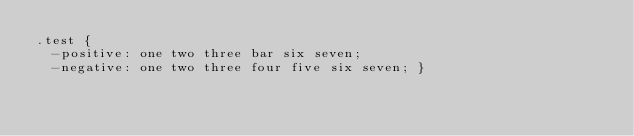Convert code to text. <code><loc_0><loc_0><loc_500><loc_500><_CSS_>.test {
  -positive: one two three bar six seven;
  -negative: one two three four five six seven; }
</code> 